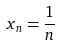<formula> <loc_0><loc_0><loc_500><loc_500>x _ { n } = \frac { 1 } { n }</formula> 